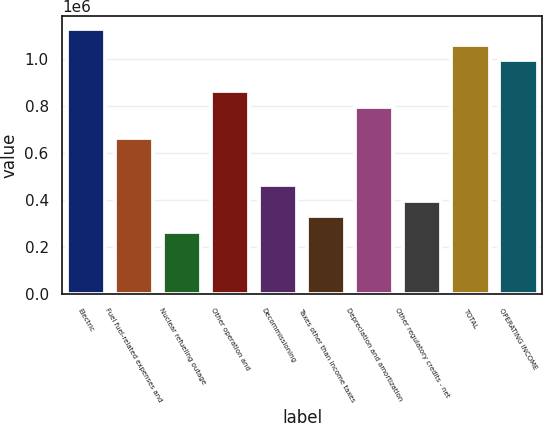Convert chart to OTSL. <chart><loc_0><loc_0><loc_500><loc_500><bar_chart><fcel>Electric<fcel>Fuel fuel-related expenses and<fcel>Nuclear refueling outage<fcel>Other operation and<fcel>Decommissioning<fcel>Taxes other than income taxes<fcel>Depreciation and amortization<fcel>Other regulatory credits - net<fcel>TOTAL<fcel>OPERATING INCOME<nl><fcel>1.12905e+06<fcel>664364<fcel>266063<fcel>863514<fcel>465214<fcel>332446<fcel>797131<fcel>398830<fcel>1.06266e+06<fcel>996282<nl></chart> 